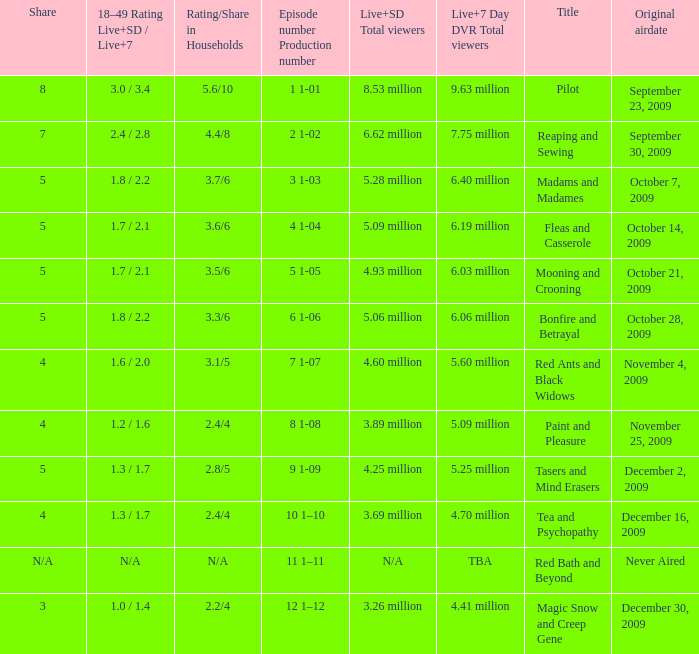What are the "18–49 Rating Live+SD" ratings and "Live+7" ratings, respectively, for the episode that originally aired on October 14, 2009? 1.7 / 2.1. 